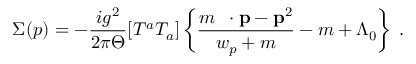<formula> <loc_0><loc_0><loc_500><loc_500>\Sigma ( p ) = - \frac { i g ^ { 2 } } { 2 \pi \Theta } [ T ^ { a } T _ { a } ] \left \{ \frac { m \, { \gamma } \cdot { p } - { p } ^ { 2 } } { w _ { p } + m } - m + \Lambda _ { 0 } \right \} \, .</formula> 